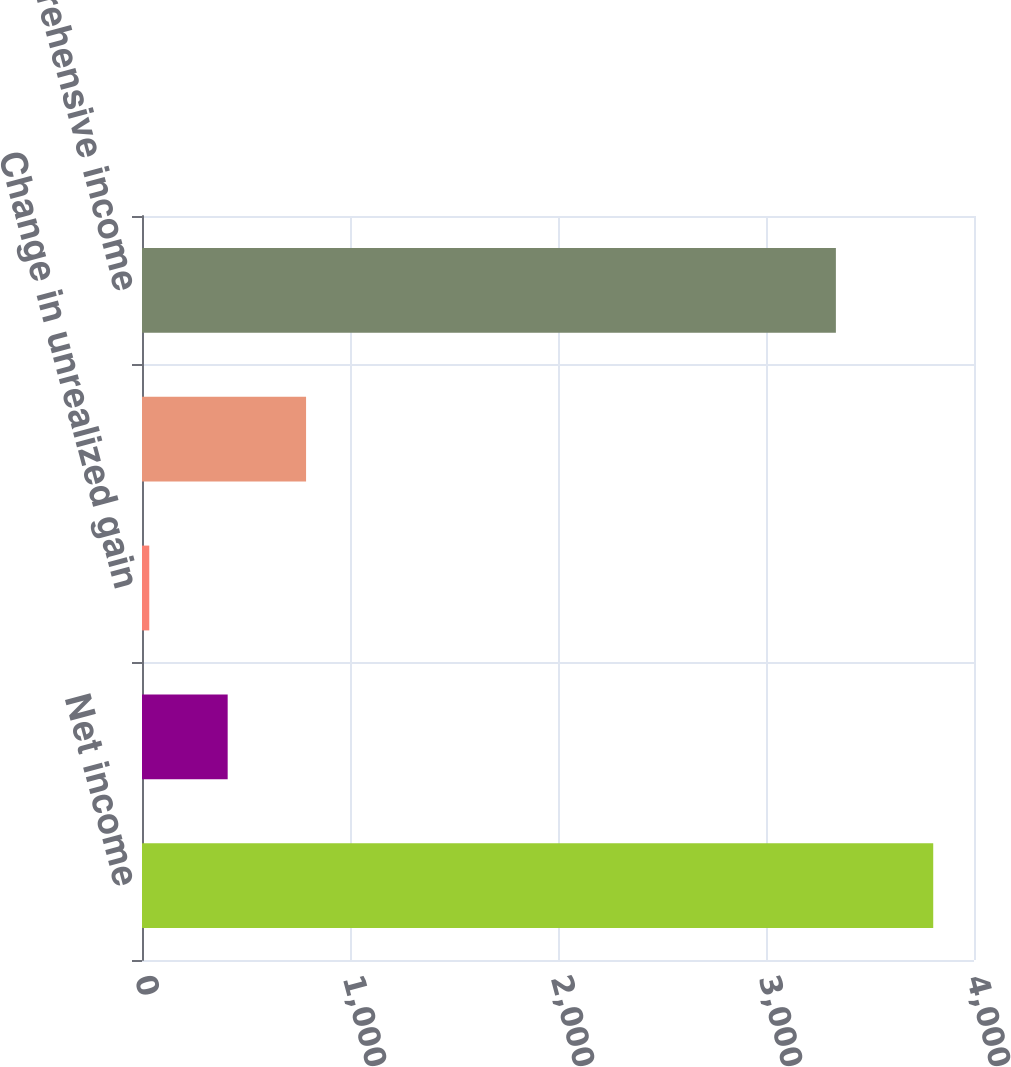<chart> <loc_0><loc_0><loc_500><loc_500><bar_chart><fcel>Net income<fcel>Change in foreign currency<fcel>Change in unrealized gain<fcel>Change in unrecognized pension<fcel>Comprehensive income<nl><fcel>3804<fcel>411.9<fcel>35<fcel>788.8<fcel>3336<nl></chart> 